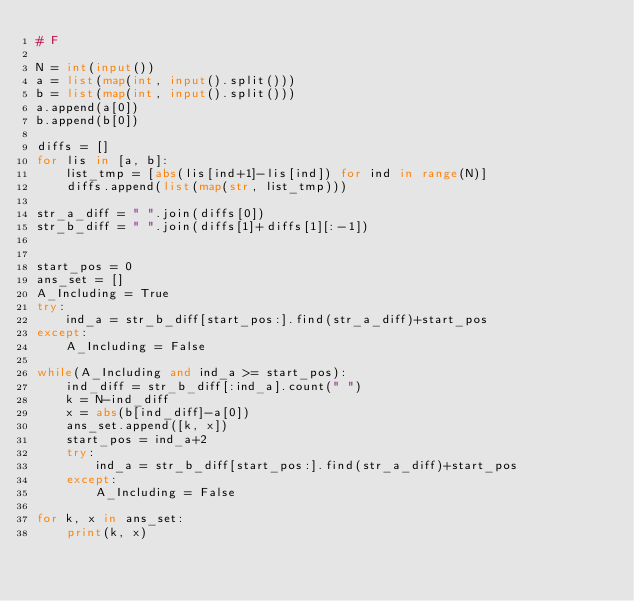<code> <loc_0><loc_0><loc_500><loc_500><_Python_># F

N = int(input())
a = list(map(int, input().split()))
b = list(map(int, input().split()))
a.append(a[0])
b.append(b[0])

diffs = []
for lis in [a, b]:
    list_tmp = [abs(lis[ind+1]-lis[ind]) for ind in range(N)]
    diffs.append(list(map(str, list_tmp)))

str_a_diff = " ".join(diffs[0])
str_b_diff = " ".join(diffs[1]+diffs[1][:-1])


start_pos = 0
ans_set = []
A_Including = True
try:
    ind_a = str_b_diff[start_pos:].find(str_a_diff)+start_pos
except:
    A_Including = False

while(A_Including and ind_a >= start_pos):
    ind_diff = str_b_diff[:ind_a].count(" ")
    k = N-ind_diff
    x = abs(b[ind_diff]-a[0])
    ans_set.append([k, x])
    start_pos = ind_a+2
    try:
        ind_a = str_b_diff[start_pos:].find(str_a_diff)+start_pos
    except:
        A_Including = False

for k, x in ans_set:
    print(k, x)</code> 